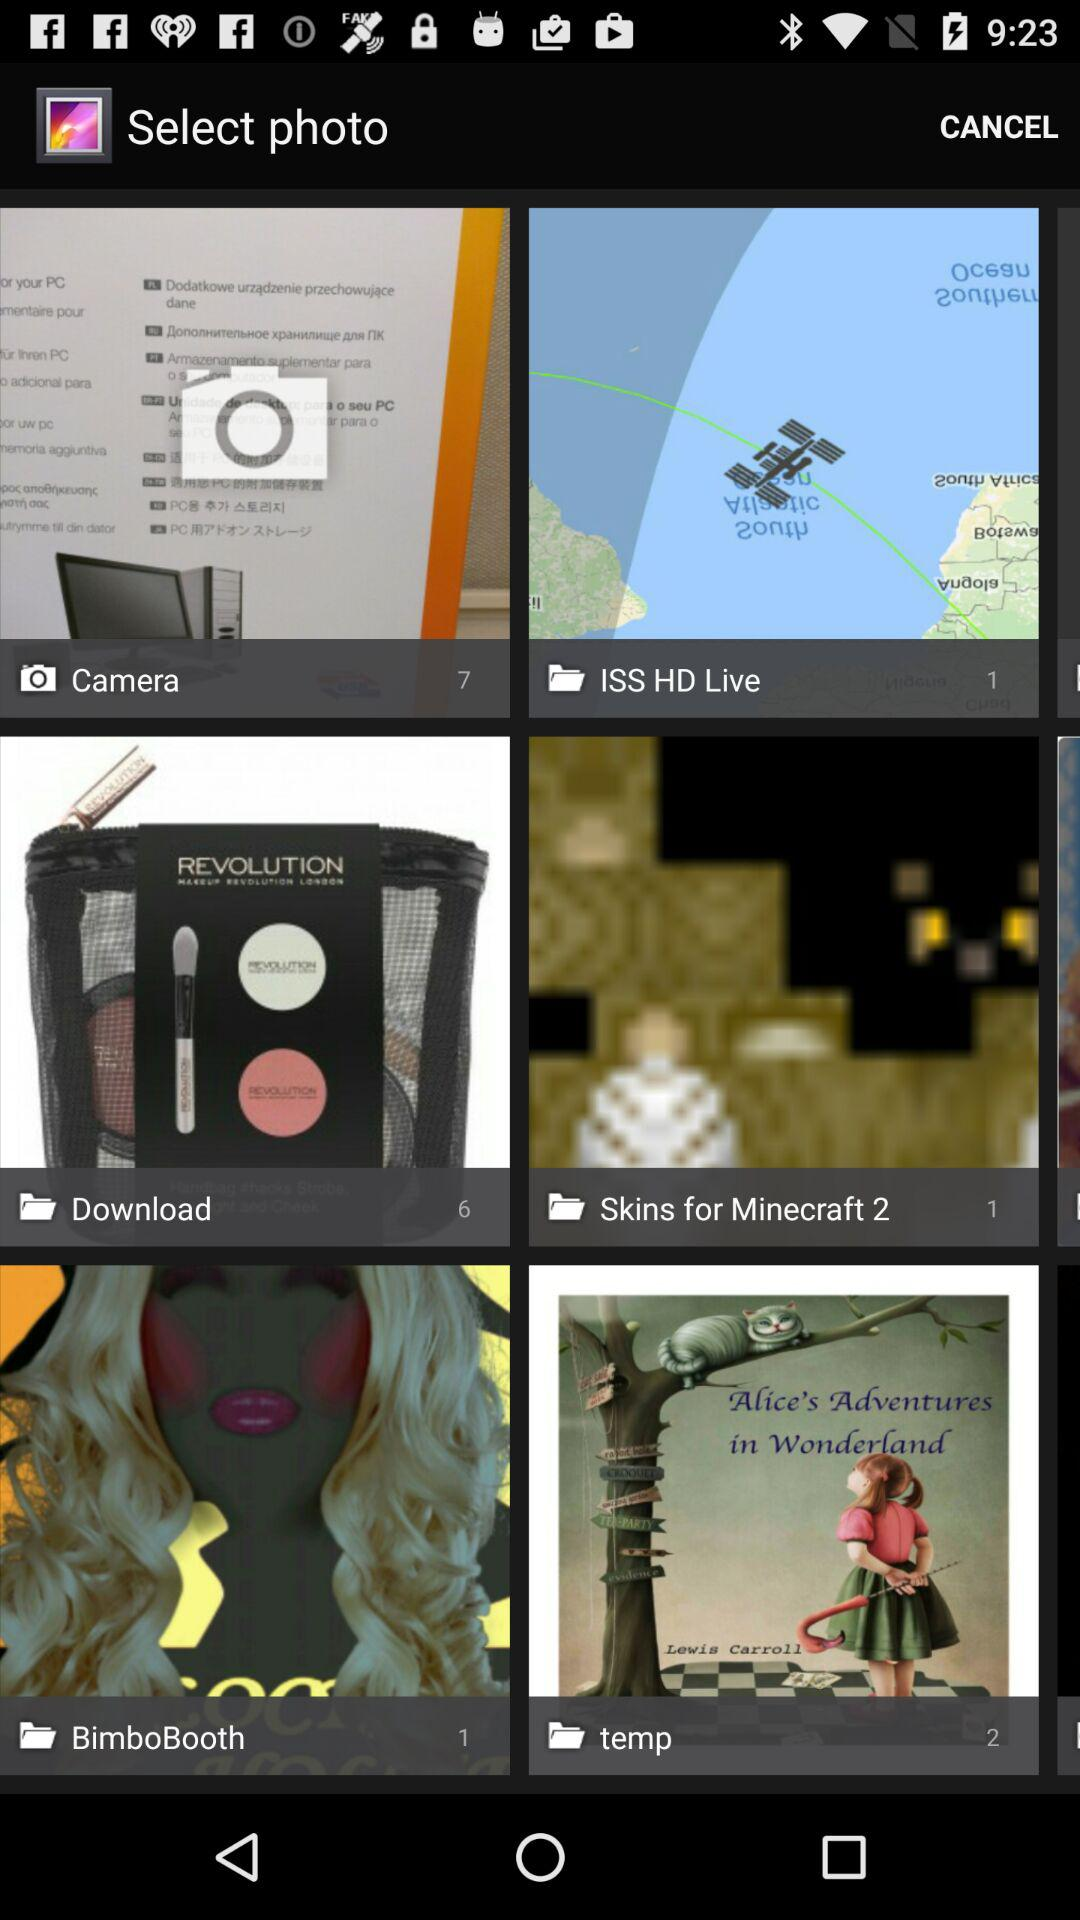How many photos does temp contain? Temp contains 2 photos. 